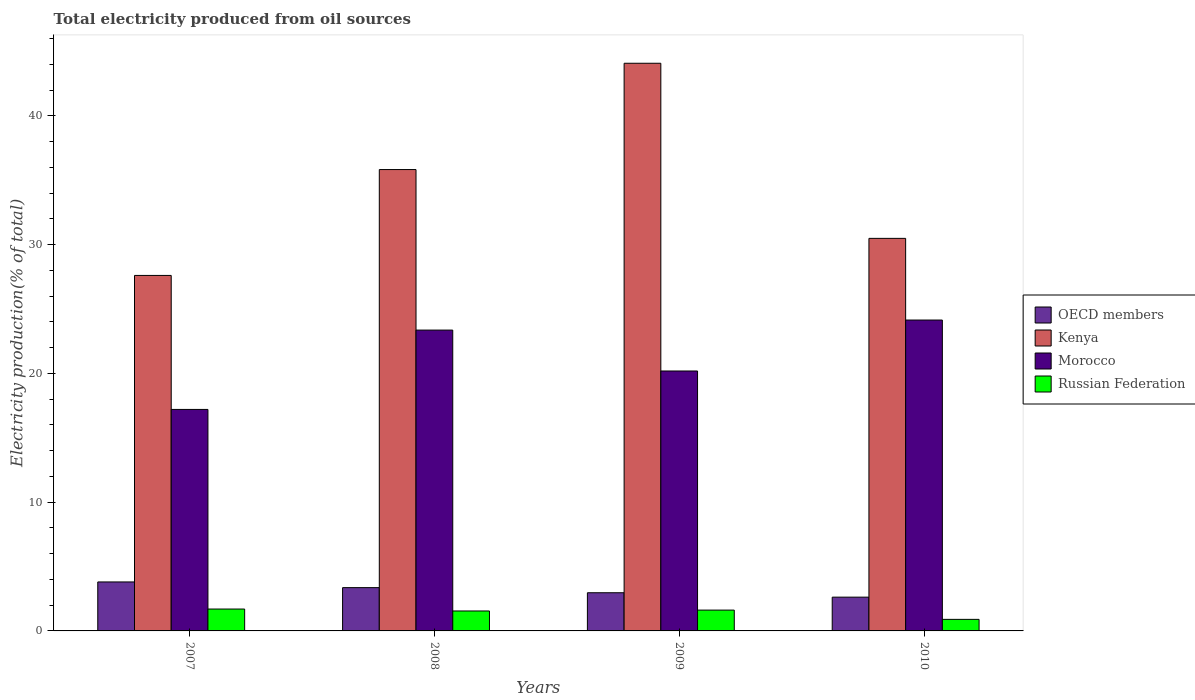How many different coloured bars are there?
Make the answer very short. 4. Are the number of bars per tick equal to the number of legend labels?
Your response must be concise. Yes. Are the number of bars on each tick of the X-axis equal?
Offer a terse response. Yes. How many bars are there on the 4th tick from the right?
Offer a very short reply. 4. What is the total electricity produced in OECD members in 2009?
Offer a very short reply. 2.96. Across all years, what is the maximum total electricity produced in Morocco?
Your answer should be compact. 24.15. Across all years, what is the minimum total electricity produced in Russian Federation?
Give a very brief answer. 0.9. In which year was the total electricity produced in Morocco maximum?
Make the answer very short. 2010. What is the total total electricity produced in Russian Federation in the graph?
Provide a short and direct response. 5.76. What is the difference between the total electricity produced in Russian Federation in 2008 and that in 2009?
Give a very brief answer. -0.07. What is the difference between the total electricity produced in OECD members in 2007 and the total electricity produced in Kenya in 2009?
Offer a terse response. -40.29. What is the average total electricity produced in Kenya per year?
Your answer should be compact. 34.51. In the year 2009, what is the difference between the total electricity produced in Morocco and total electricity produced in Kenya?
Your answer should be very brief. -23.9. In how many years, is the total electricity produced in Morocco greater than 10 %?
Offer a very short reply. 4. What is the ratio of the total electricity produced in OECD members in 2008 to that in 2010?
Provide a short and direct response. 1.28. What is the difference between the highest and the second highest total electricity produced in Kenya?
Make the answer very short. 8.26. What is the difference between the highest and the lowest total electricity produced in Russian Federation?
Keep it short and to the point. 0.8. In how many years, is the total electricity produced in Russian Federation greater than the average total electricity produced in Russian Federation taken over all years?
Make the answer very short. 3. Is it the case that in every year, the sum of the total electricity produced in Kenya and total electricity produced in Morocco is greater than the sum of total electricity produced in Russian Federation and total electricity produced in OECD members?
Offer a terse response. No. What does the 2nd bar from the left in 2009 represents?
Keep it short and to the point. Kenya. How many bars are there?
Offer a terse response. 16. Are all the bars in the graph horizontal?
Ensure brevity in your answer.  No. Does the graph contain grids?
Provide a succinct answer. No. Where does the legend appear in the graph?
Offer a terse response. Center right. How are the legend labels stacked?
Your answer should be compact. Vertical. What is the title of the graph?
Keep it short and to the point. Total electricity produced from oil sources. What is the label or title of the X-axis?
Give a very brief answer. Years. What is the Electricity production(% of total) of OECD members in 2007?
Your response must be concise. 3.8. What is the Electricity production(% of total) of Kenya in 2007?
Make the answer very short. 27.61. What is the Electricity production(% of total) of Morocco in 2007?
Provide a succinct answer. 17.2. What is the Electricity production(% of total) of Russian Federation in 2007?
Provide a succinct answer. 1.7. What is the Electricity production(% of total) of OECD members in 2008?
Offer a terse response. 3.36. What is the Electricity production(% of total) of Kenya in 2008?
Your answer should be compact. 35.83. What is the Electricity production(% of total) of Morocco in 2008?
Offer a terse response. 23.37. What is the Electricity production(% of total) of Russian Federation in 2008?
Provide a succinct answer. 1.55. What is the Electricity production(% of total) of OECD members in 2009?
Provide a short and direct response. 2.96. What is the Electricity production(% of total) of Kenya in 2009?
Your answer should be compact. 44.09. What is the Electricity production(% of total) in Morocco in 2009?
Make the answer very short. 20.19. What is the Electricity production(% of total) in Russian Federation in 2009?
Offer a very short reply. 1.62. What is the Electricity production(% of total) of OECD members in 2010?
Offer a very short reply. 2.62. What is the Electricity production(% of total) of Kenya in 2010?
Ensure brevity in your answer.  30.49. What is the Electricity production(% of total) in Morocco in 2010?
Ensure brevity in your answer.  24.15. What is the Electricity production(% of total) of Russian Federation in 2010?
Offer a terse response. 0.9. Across all years, what is the maximum Electricity production(% of total) in OECD members?
Offer a terse response. 3.8. Across all years, what is the maximum Electricity production(% of total) of Kenya?
Provide a short and direct response. 44.09. Across all years, what is the maximum Electricity production(% of total) in Morocco?
Make the answer very short. 24.15. Across all years, what is the maximum Electricity production(% of total) in Russian Federation?
Keep it short and to the point. 1.7. Across all years, what is the minimum Electricity production(% of total) of OECD members?
Offer a terse response. 2.62. Across all years, what is the minimum Electricity production(% of total) in Kenya?
Provide a succinct answer. 27.61. Across all years, what is the minimum Electricity production(% of total) in Morocco?
Provide a short and direct response. 17.2. Across all years, what is the minimum Electricity production(% of total) in Russian Federation?
Your response must be concise. 0.9. What is the total Electricity production(% of total) of OECD members in the graph?
Provide a succinct answer. 12.75. What is the total Electricity production(% of total) in Kenya in the graph?
Your answer should be compact. 138.03. What is the total Electricity production(% of total) in Morocco in the graph?
Offer a very short reply. 84.91. What is the total Electricity production(% of total) of Russian Federation in the graph?
Keep it short and to the point. 5.76. What is the difference between the Electricity production(% of total) in OECD members in 2007 and that in 2008?
Offer a very short reply. 0.44. What is the difference between the Electricity production(% of total) of Kenya in 2007 and that in 2008?
Offer a terse response. -8.22. What is the difference between the Electricity production(% of total) in Morocco in 2007 and that in 2008?
Your response must be concise. -6.16. What is the difference between the Electricity production(% of total) in Russian Federation in 2007 and that in 2008?
Keep it short and to the point. 0.15. What is the difference between the Electricity production(% of total) in OECD members in 2007 and that in 2009?
Make the answer very short. 0.84. What is the difference between the Electricity production(% of total) of Kenya in 2007 and that in 2009?
Keep it short and to the point. -16.48. What is the difference between the Electricity production(% of total) in Morocco in 2007 and that in 2009?
Your answer should be very brief. -2.99. What is the difference between the Electricity production(% of total) in Russian Federation in 2007 and that in 2009?
Give a very brief answer. 0.08. What is the difference between the Electricity production(% of total) of OECD members in 2007 and that in 2010?
Provide a short and direct response. 1.18. What is the difference between the Electricity production(% of total) of Kenya in 2007 and that in 2010?
Keep it short and to the point. -2.88. What is the difference between the Electricity production(% of total) of Morocco in 2007 and that in 2010?
Provide a short and direct response. -6.94. What is the difference between the Electricity production(% of total) of Russian Federation in 2007 and that in 2010?
Your response must be concise. 0.8. What is the difference between the Electricity production(% of total) of OECD members in 2008 and that in 2009?
Your response must be concise. 0.4. What is the difference between the Electricity production(% of total) in Kenya in 2008 and that in 2009?
Your response must be concise. -8.26. What is the difference between the Electricity production(% of total) of Morocco in 2008 and that in 2009?
Give a very brief answer. 3.18. What is the difference between the Electricity production(% of total) of Russian Federation in 2008 and that in 2009?
Give a very brief answer. -0.07. What is the difference between the Electricity production(% of total) in OECD members in 2008 and that in 2010?
Offer a very short reply. 0.74. What is the difference between the Electricity production(% of total) of Kenya in 2008 and that in 2010?
Make the answer very short. 5.35. What is the difference between the Electricity production(% of total) of Morocco in 2008 and that in 2010?
Provide a short and direct response. -0.78. What is the difference between the Electricity production(% of total) of Russian Federation in 2008 and that in 2010?
Your answer should be compact. 0.65. What is the difference between the Electricity production(% of total) of OECD members in 2009 and that in 2010?
Your response must be concise. 0.34. What is the difference between the Electricity production(% of total) of Kenya in 2009 and that in 2010?
Make the answer very short. 13.6. What is the difference between the Electricity production(% of total) of Morocco in 2009 and that in 2010?
Offer a terse response. -3.96. What is the difference between the Electricity production(% of total) in Russian Federation in 2009 and that in 2010?
Your answer should be compact. 0.72. What is the difference between the Electricity production(% of total) of OECD members in 2007 and the Electricity production(% of total) of Kenya in 2008?
Offer a very short reply. -32.03. What is the difference between the Electricity production(% of total) of OECD members in 2007 and the Electricity production(% of total) of Morocco in 2008?
Your answer should be compact. -19.56. What is the difference between the Electricity production(% of total) of OECD members in 2007 and the Electricity production(% of total) of Russian Federation in 2008?
Your answer should be compact. 2.26. What is the difference between the Electricity production(% of total) of Kenya in 2007 and the Electricity production(% of total) of Morocco in 2008?
Give a very brief answer. 4.25. What is the difference between the Electricity production(% of total) of Kenya in 2007 and the Electricity production(% of total) of Russian Federation in 2008?
Your answer should be compact. 26.06. What is the difference between the Electricity production(% of total) in Morocco in 2007 and the Electricity production(% of total) in Russian Federation in 2008?
Offer a terse response. 15.65. What is the difference between the Electricity production(% of total) of OECD members in 2007 and the Electricity production(% of total) of Kenya in 2009?
Provide a short and direct response. -40.29. What is the difference between the Electricity production(% of total) of OECD members in 2007 and the Electricity production(% of total) of Morocco in 2009?
Your answer should be very brief. -16.38. What is the difference between the Electricity production(% of total) of OECD members in 2007 and the Electricity production(% of total) of Russian Federation in 2009?
Your answer should be very brief. 2.19. What is the difference between the Electricity production(% of total) of Kenya in 2007 and the Electricity production(% of total) of Morocco in 2009?
Provide a succinct answer. 7.42. What is the difference between the Electricity production(% of total) in Kenya in 2007 and the Electricity production(% of total) in Russian Federation in 2009?
Your response must be concise. 25.99. What is the difference between the Electricity production(% of total) of Morocco in 2007 and the Electricity production(% of total) of Russian Federation in 2009?
Your response must be concise. 15.59. What is the difference between the Electricity production(% of total) in OECD members in 2007 and the Electricity production(% of total) in Kenya in 2010?
Your answer should be compact. -26.68. What is the difference between the Electricity production(% of total) of OECD members in 2007 and the Electricity production(% of total) of Morocco in 2010?
Your response must be concise. -20.34. What is the difference between the Electricity production(% of total) in OECD members in 2007 and the Electricity production(% of total) in Russian Federation in 2010?
Offer a very short reply. 2.91. What is the difference between the Electricity production(% of total) of Kenya in 2007 and the Electricity production(% of total) of Morocco in 2010?
Ensure brevity in your answer.  3.46. What is the difference between the Electricity production(% of total) of Kenya in 2007 and the Electricity production(% of total) of Russian Federation in 2010?
Give a very brief answer. 26.71. What is the difference between the Electricity production(% of total) in Morocco in 2007 and the Electricity production(% of total) in Russian Federation in 2010?
Offer a terse response. 16.31. What is the difference between the Electricity production(% of total) in OECD members in 2008 and the Electricity production(% of total) in Kenya in 2009?
Keep it short and to the point. -40.73. What is the difference between the Electricity production(% of total) in OECD members in 2008 and the Electricity production(% of total) in Morocco in 2009?
Your answer should be very brief. -16.83. What is the difference between the Electricity production(% of total) in OECD members in 2008 and the Electricity production(% of total) in Russian Federation in 2009?
Your answer should be very brief. 1.75. What is the difference between the Electricity production(% of total) in Kenya in 2008 and the Electricity production(% of total) in Morocco in 2009?
Ensure brevity in your answer.  15.65. What is the difference between the Electricity production(% of total) in Kenya in 2008 and the Electricity production(% of total) in Russian Federation in 2009?
Offer a very short reply. 34.22. What is the difference between the Electricity production(% of total) of Morocco in 2008 and the Electricity production(% of total) of Russian Federation in 2009?
Your answer should be very brief. 21.75. What is the difference between the Electricity production(% of total) in OECD members in 2008 and the Electricity production(% of total) in Kenya in 2010?
Give a very brief answer. -27.13. What is the difference between the Electricity production(% of total) of OECD members in 2008 and the Electricity production(% of total) of Morocco in 2010?
Make the answer very short. -20.78. What is the difference between the Electricity production(% of total) of OECD members in 2008 and the Electricity production(% of total) of Russian Federation in 2010?
Offer a terse response. 2.46. What is the difference between the Electricity production(% of total) of Kenya in 2008 and the Electricity production(% of total) of Morocco in 2010?
Offer a very short reply. 11.69. What is the difference between the Electricity production(% of total) in Kenya in 2008 and the Electricity production(% of total) in Russian Federation in 2010?
Offer a terse response. 34.94. What is the difference between the Electricity production(% of total) in Morocco in 2008 and the Electricity production(% of total) in Russian Federation in 2010?
Your answer should be compact. 22.47. What is the difference between the Electricity production(% of total) of OECD members in 2009 and the Electricity production(% of total) of Kenya in 2010?
Offer a terse response. -27.52. What is the difference between the Electricity production(% of total) in OECD members in 2009 and the Electricity production(% of total) in Morocco in 2010?
Keep it short and to the point. -21.18. What is the difference between the Electricity production(% of total) in OECD members in 2009 and the Electricity production(% of total) in Russian Federation in 2010?
Your answer should be compact. 2.07. What is the difference between the Electricity production(% of total) in Kenya in 2009 and the Electricity production(% of total) in Morocco in 2010?
Provide a succinct answer. 19.94. What is the difference between the Electricity production(% of total) in Kenya in 2009 and the Electricity production(% of total) in Russian Federation in 2010?
Make the answer very short. 43.19. What is the difference between the Electricity production(% of total) in Morocco in 2009 and the Electricity production(% of total) in Russian Federation in 2010?
Give a very brief answer. 19.29. What is the average Electricity production(% of total) of OECD members per year?
Keep it short and to the point. 3.19. What is the average Electricity production(% of total) in Kenya per year?
Provide a succinct answer. 34.51. What is the average Electricity production(% of total) in Morocco per year?
Provide a short and direct response. 21.23. What is the average Electricity production(% of total) of Russian Federation per year?
Ensure brevity in your answer.  1.44. In the year 2007, what is the difference between the Electricity production(% of total) of OECD members and Electricity production(% of total) of Kenya?
Make the answer very short. -23.81. In the year 2007, what is the difference between the Electricity production(% of total) of OECD members and Electricity production(% of total) of Morocco?
Provide a short and direct response. -13.4. In the year 2007, what is the difference between the Electricity production(% of total) in OECD members and Electricity production(% of total) in Russian Federation?
Your answer should be compact. 2.11. In the year 2007, what is the difference between the Electricity production(% of total) of Kenya and Electricity production(% of total) of Morocco?
Your response must be concise. 10.41. In the year 2007, what is the difference between the Electricity production(% of total) of Kenya and Electricity production(% of total) of Russian Federation?
Make the answer very short. 25.91. In the year 2007, what is the difference between the Electricity production(% of total) in Morocco and Electricity production(% of total) in Russian Federation?
Make the answer very short. 15.5. In the year 2008, what is the difference between the Electricity production(% of total) of OECD members and Electricity production(% of total) of Kenya?
Your response must be concise. -32.47. In the year 2008, what is the difference between the Electricity production(% of total) of OECD members and Electricity production(% of total) of Morocco?
Your answer should be very brief. -20. In the year 2008, what is the difference between the Electricity production(% of total) of OECD members and Electricity production(% of total) of Russian Federation?
Keep it short and to the point. 1.81. In the year 2008, what is the difference between the Electricity production(% of total) of Kenya and Electricity production(% of total) of Morocco?
Make the answer very short. 12.47. In the year 2008, what is the difference between the Electricity production(% of total) in Kenya and Electricity production(% of total) in Russian Federation?
Provide a succinct answer. 34.29. In the year 2008, what is the difference between the Electricity production(% of total) of Morocco and Electricity production(% of total) of Russian Federation?
Provide a short and direct response. 21.82. In the year 2009, what is the difference between the Electricity production(% of total) in OECD members and Electricity production(% of total) in Kenya?
Give a very brief answer. -41.13. In the year 2009, what is the difference between the Electricity production(% of total) of OECD members and Electricity production(% of total) of Morocco?
Offer a terse response. -17.22. In the year 2009, what is the difference between the Electricity production(% of total) in OECD members and Electricity production(% of total) in Russian Federation?
Provide a short and direct response. 1.35. In the year 2009, what is the difference between the Electricity production(% of total) of Kenya and Electricity production(% of total) of Morocco?
Ensure brevity in your answer.  23.9. In the year 2009, what is the difference between the Electricity production(% of total) in Kenya and Electricity production(% of total) in Russian Federation?
Ensure brevity in your answer.  42.47. In the year 2009, what is the difference between the Electricity production(% of total) in Morocco and Electricity production(% of total) in Russian Federation?
Your response must be concise. 18.57. In the year 2010, what is the difference between the Electricity production(% of total) of OECD members and Electricity production(% of total) of Kenya?
Make the answer very short. -27.87. In the year 2010, what is the difference between the Electricity production(% of total) of OECD members and Electricity production(% of total) of Morocco?
Give a very brief answer. -21.52. In the year 2010, what is the difference between the Electricity production(% of total) of OECD members and Electricity production(% of total) of Russian Federation?
Ensure brevity in your answer.  1.73. In the year 2010, what is the difference between the Electricity production(% of total) of Kenya and Electricity production(% of total) of Morocco?
Offer a terse response. 6.34. In the year 2010, what is the difference between the Electricity production(% of total) in Kenya and Electricity production(% of total) in Russian Federation?
Your answer should be compact. 29.59. In the year 2010, what is the difference between the Electricity production(% of total) in Morocco and Electricity production(% of total) in Russian Federation?
Offer a very short reply. 23.25. What is the ratio of the Electricity production(% of total) in OECD members in 2007 to that in 2008?
Keep it short and to the point. 1.13. What is the ratio of the Electricity production(% of total) in Kenya in 2007 to that in 2008?
Your answer should be compact. 0.77. What is the ratio of the Electricity production(% of total) in Morocco in 2007 to that in 2008?
Your response must be concise. 0.74. What is the ratio of the Electricity production(% of total) of Russian Federation in 2007 to that in 2008?
Provide a short and direct response. 1.1. What is the ratio of the Electricity production(% of total) in OECD members in 2007 to that in 2009?
Ensure brevity in your answer.  1.28. What is the ratio of the Electricity production(% of total) of Kenya in 2007 to that in 2009?
Offer a terse response. 0.63. What is the ratio of the Electricity production(% of total) of Morocco in 2007 to that in 2009?
Keep it short and to the point. 0.85. What is the ratio of the Electricity production(% of total) in Russian Federation in 2007 to that in 2009?
Offer a very short reply. 1.05. What is the ratio of the Electricity production(% of total) in OECD members in 2007 to that in 2010?
Ensure brevity in your answer.  1.45. What is the ratio of the Electricity production(% of total) in Kenya in 2007 to that in 2010?
Your answer should be very brief. 0.91. What is the ratio of the Electricity production(% of total) of Morocco in 2007 to that in 2010?
Provide a succinct answer. 0.71. What is the ratio of the Electricity production(% of total) of Russian Federation in 2007 to that in 2010?
Provide a succinct answer. 1.89. What is the ratio of the Electricity production(% of total) in OECD members in 2008 to that in 2009?
Offer a very short reply. 1.13. What is the ratio of the Electricity production(% of total) in Kenya in 2008 to that in 2009?
Your answer should be very brief. 0.81. What is the ratio of the Electricity production(% of total) in Morocco in 2008 to that in 2009?
Give a very brief answer. 1.16. What is the ratio of the Electricity production(% of total) in Russian Federation in 2008 to that in 2009?
Provide a short and direct response. 0.96. What is the ratio of the Electricity production(% of total) in OECD members in 2008 to that in 2010?
Offer a terse response. 1.28. What is the ratio of the Electricity production(% of total) of Kenya in 2008 to that in 2010?
Make the answer very short. 1.18. What is the ratio of the Electricity production(% of total) in Morocco in 2008 to that in 2010?
Your answer should be compact. 0.97. What is the ratio of the Electricity production(% of total) of Russian Federation in 2008 to that in 2010?
Ensure brevity in your answer.  1.73. What is the ratio of the Electricity production(% of total) of OECD members in 2009 to that in 2010?
Ensure brevity in your answer.  1.13. What is the ratio of the Electricity production(% of total) in Kenya in 2009 to that in 2010?
Offer a terse response. 1.45. What is the ratio of the Electricity production(% of total) of Morocco in 2009 to that in 2010?
Give a very brief answer. 0.84. What is the ratio of the Electricity production(% of total) in Russian Federation in 2009 to that in 2010?
Provide a short and direct response. 1.8. What is the difference between the highest and the second highest Electricity production(% of total) in OECD members?
Provide a succinct answer. 0.44. What is the difference between the highest and the second highest Electricity production(% of total) of Kenya?
Your answer should be compact. 8.26. What is the difference between the highest and the second highest Electricity production(% of total) in Morocco?
Offer a very short reply. 0.78. What is the difference between the highest and the second highest Electricity production(% of total) of Russian Federation?
Keep it short and to the point. 0.08. What is the difference between the highest and the lowest Electricity production(% of total) of OECD members?
Give a very brief answer. 1.18. What is the difference between the highest and the lowest Electricity production(% of total) of Kenya?
Give a very brief answer. 16.48. What is the difference between the highest and the lowest Electricity production(% of total) in Morocco?
Offer a very short reply. 6.94. What is the difference between the highest and the lowest Electricity production(% of total) of Russian Federation?
Provide a short and direct response. 0.8. 